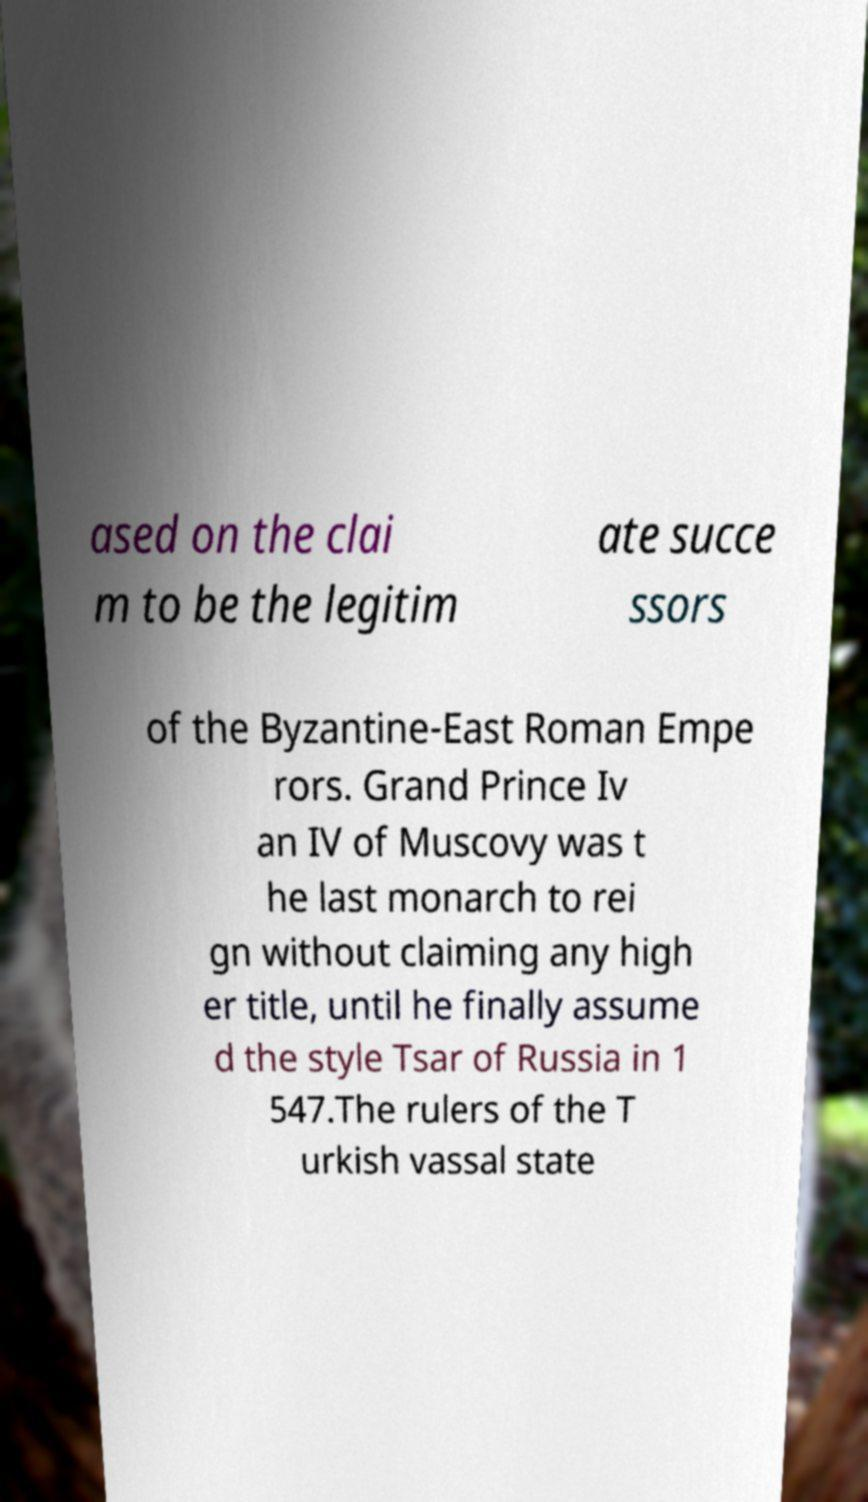Can you accurately transcribe the text from the provided image for me? ased on the clai m to be the legitim ate succe ssors of the Byzantine-East Roman Empe rors. Grand Prince Iv an IV of Muscovy was t he last monarch to rei gn without claiming any high er title, until he finally assume d the style Tsar of Russia in 1 547.The rulers of the T urkish vassal state 